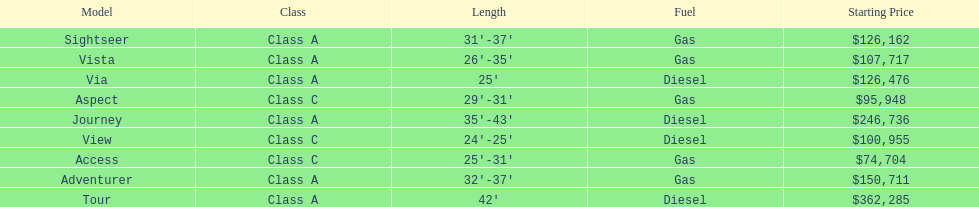Which model had the highest starting price Tour. 